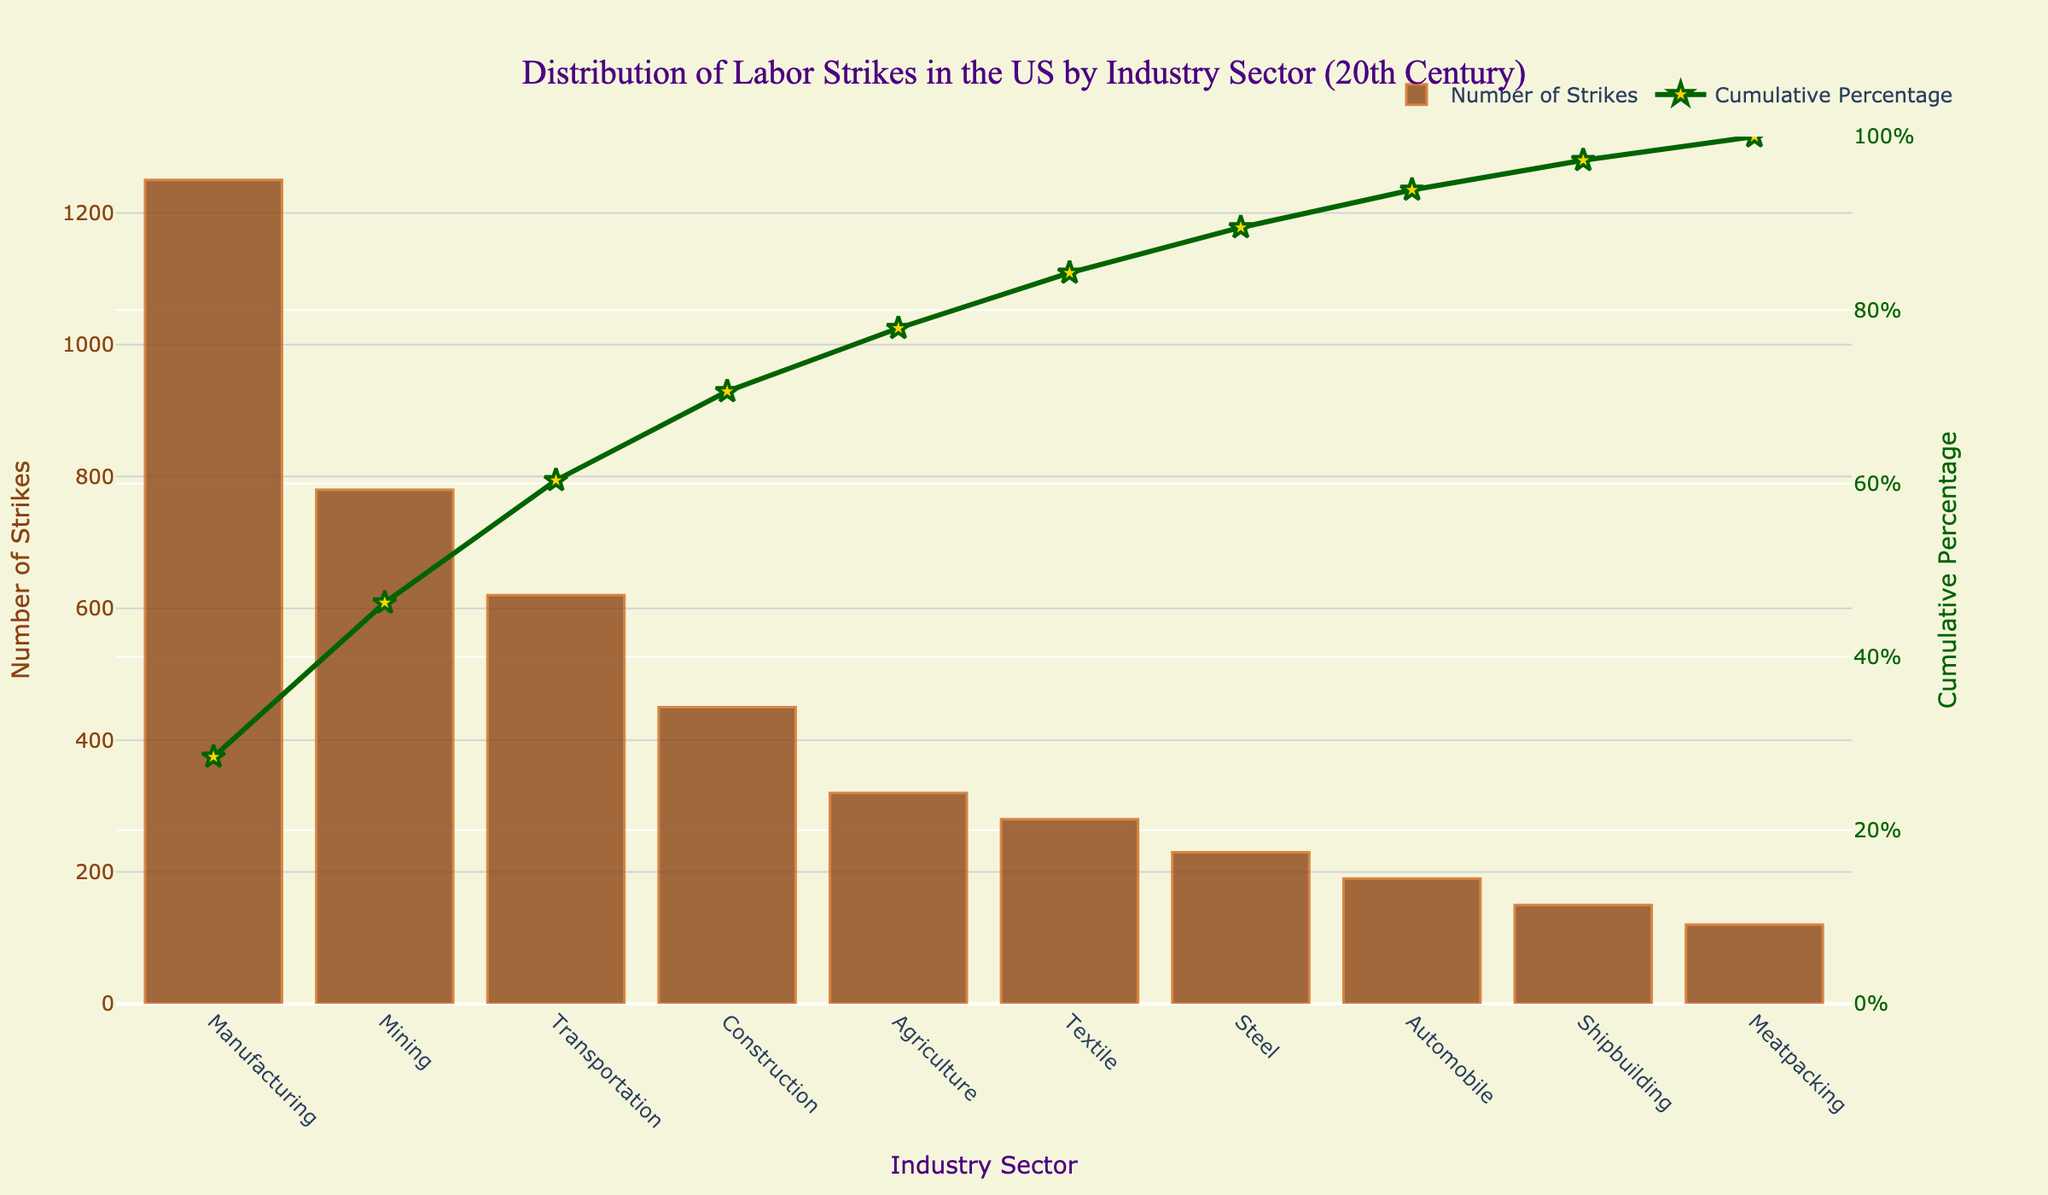What is the title of the figure? The title of the figure is located at the top of the chart. It reads "Distribution of Labor Strikes in the US by Industry Sector (20th Century)."
Answer: Distribution of Labor Strikes in the US by Industry Sector (20th Century) Which industry sector has the highest number of labor strikes? To determine the industry sector with the highest number of labor strikes, look for the tallest bar in the chart. The Manufacturing sector has the highest value bar.
Answer: Manufacturing What percentage of strikes does the Manufacturing sector contribute to the total? The cumulative percentage for the Manufacturing sector's position on the curve represents its contribution to the total. It's the first data point on the line, which shows approximately 31%.
Answer: Approximately 31% How does the number of strikes in the Mining sector compare to the Construction sector? Find the bars corresponding to Mining and Construction sectors. Mining has 780 strikes, and Construction has 450 strikes. Compare these values: 780 is greater than 450.
Answer: Mining has more strikes than Construction What are the cumulative percentages of the first three industry sectors with the highest number of strikes? Identify the first three sectors and their cumulative percentages from the curve. These first three sectors are Manufacturing (31%), Mining (31% + 19% = 50%), and Transportation (50% + 15% = 65%).
Answer: 31%, 50%, 65% Which industry sector contributes to 50% cumulative percentage of strikes? Find the point on the cumulative percentage curve that intersects 50%. This occurs at the Mining sector.
Answer: Mining What is the sum of labor strikes in the Agriculture and Textile sectors? Find the values for Agriculture (320) and Textile (280) sectors. Add these two values: 320 + 280 = 600.
Answer: 600 How many industry sectors contribute to over 75% of the cumulative labor strikes? Locate the point on the cumulative line where it surpasses 75%. Identify the sectors before and including this mark. The sectors are Manufacturing, Mining, Transportation, and Construction.
Answer: Four sectors What is the smallest number of strikes recorded and which industry sector has it? Identify the shortest bar on the chart. The Meatpacking sector has the smallest value with 120 strikes.
Answer: Meatpacking, 120 In which sector is the difference in the number of strikes from the Manufacturing sector the largest? Compare the number of strikes in all sectors to Manufacturing (1250). The largest difference is from Meatpacking (1250 - 120 = 1130).
Answer: Meatpacking 